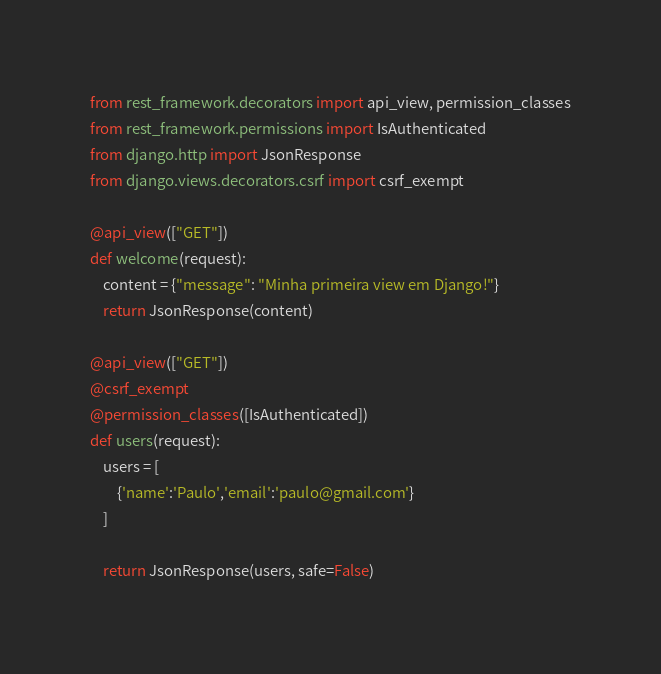<code> <loc_0><loc_0><loc_500><loc_500><_Python_>from rest_framework.decorators import api_view, permission_classes
from rest_framework.permissions import IsAuthenticated
from django.http import JsonResponse
from django.views.decorators.csrf import csrf_exempt

@api_view(["GET"])
def welcome(request):
    content = {"message": "Minha primeira view em Django!"}
    return JsonResponse(content)

@api_view(["GET"])
@csrf_exempt
@permission_classes([IsAuthenticated])
def users(request):
    users = [
        {'name':'Paulo','email':'paulo@gmail.com'}
    ]

    return JsonResponse(users, safe=False)</code> 